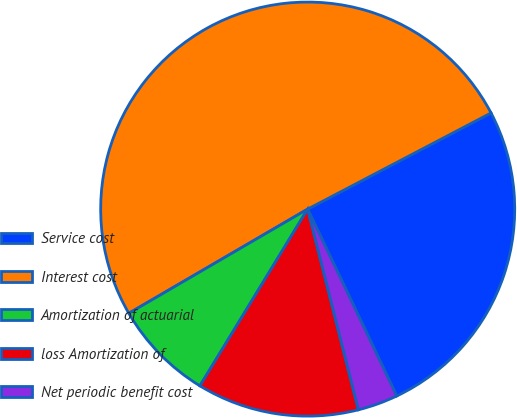<chart> <loc_0><loc_0><loc_500><loc_500><pie_chart><fcel>Service cost<fcel>Interest cost<fcel>Amortization of actuarial<fcel>loss Amortization of<fcel>Net periodic benefit cost<nl><fcel>25.61%<fcel>50.71%<fcel>7.89%<fcel>12.65%<fcel>3.14%<nl></chart> 